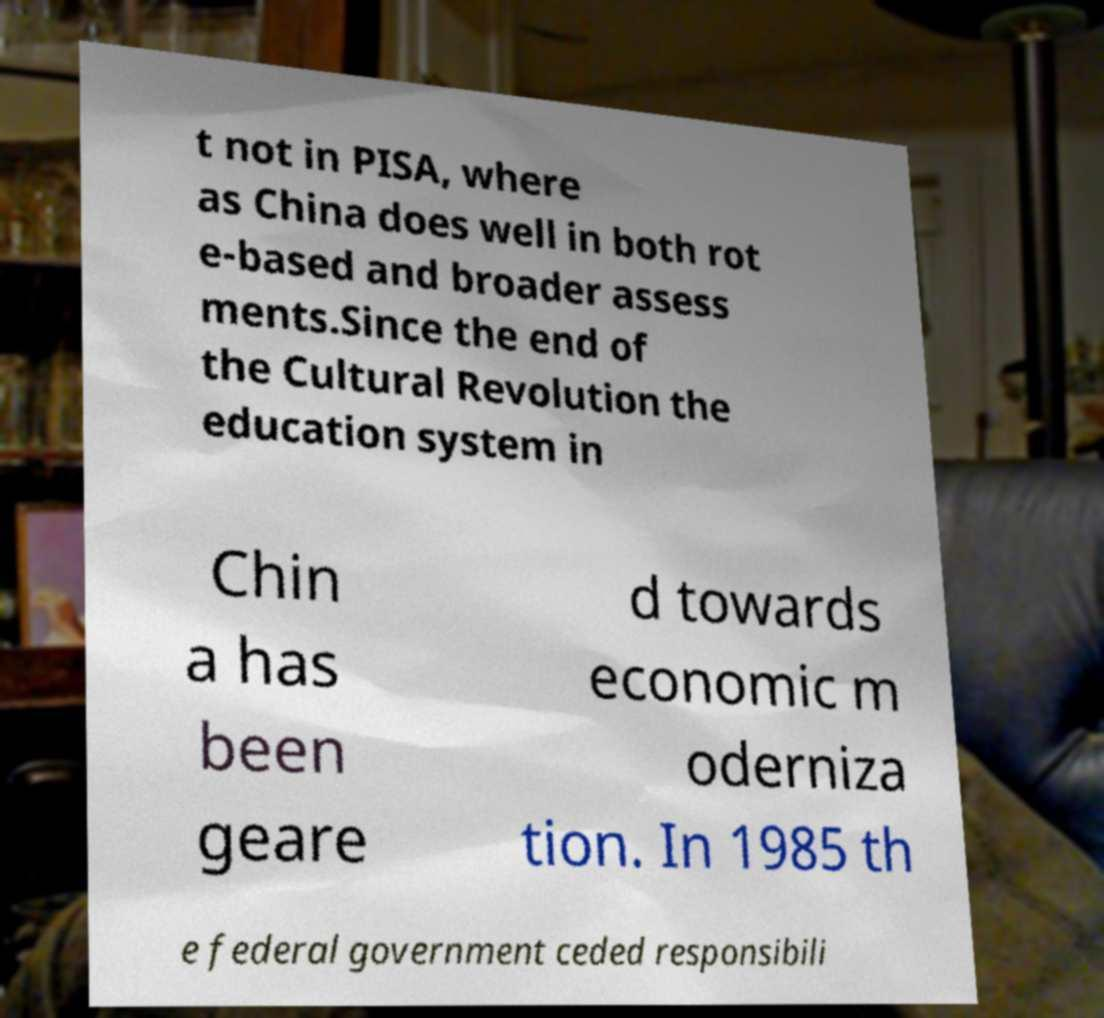Please identify and transcribe the text found in this image. t not in PISA, where as China does well in both rot e-based and broader assess ments.Since the end of the Cultural Revolution the education system in Chin a has been geare d towards economic m oderniza tion. In 1985 th e federal government ceded responsibili 